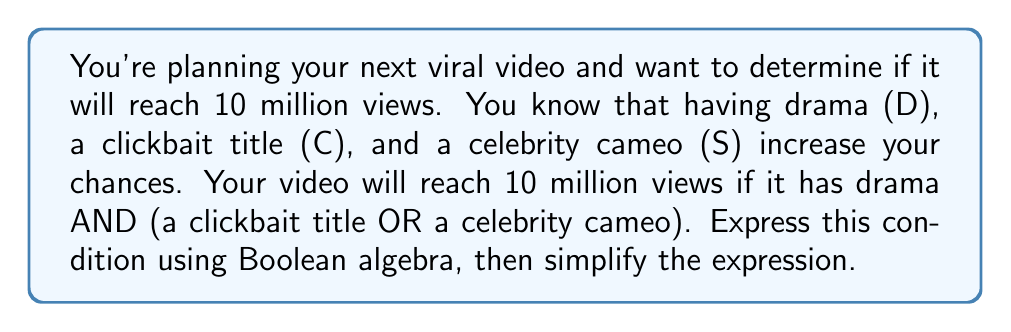Could you help me with this problem? Let's approach this step-by-step:

1) First, we need to translate the given condition into Boolean algebra:
   "Drama AND (clickbait title OR celebrity cameo)"
   
   In Boolean algebra, this can be written as:
   $$ D \cdot (C + S) $$

   Where:
   $D$ = Drama
   $C$ = Clickbait title
   $S$ = Celebrity cameo
   $\cdot$ represents AND
   $+$ represents OR

2) Now, let's simplify this expression using the distributive property of Boolean algebra:
   $$ D \cdot (C + S) = (D \cdot C) + (D \cdot S) $$

3) This simplified form tells us that the video will reach 10 million views if:
   - It has both drama and a clickbait title (D · C), OR
   - It has both drama and a celebrity cameo (D · S)

4) There's no further simplification possible for this expression.
Answer: $$(D \cdot C) + (D \cdot S)$$ 